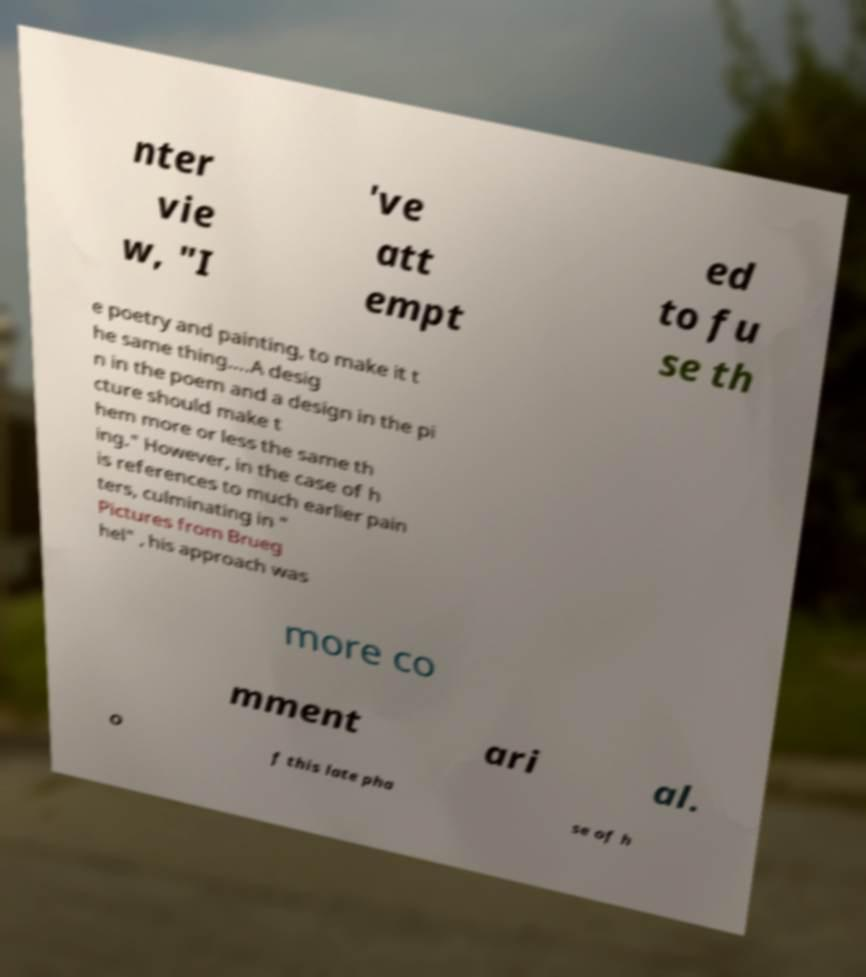Please identify and transcribe the text found in this image. nter vie w, "I 've att empt ed to fu se th e poetry and painting, to make it t he same thing….A desig n in the poem and a design in the pi cture should make t hem more or less the same th ing." However, in the case of h is references to much earlier pain ters, culminating in " Pictures from Brueg hel" , his approach was more co mment ari al. O f this late pha se of h 